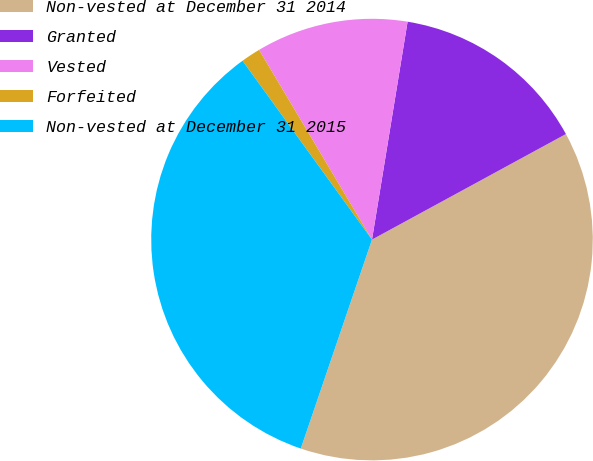<chart> <loc_0><loc_0><loc_500><loc_500><pie_chart><fcel>Non-vested at December 31 2014<fcel>Granted<fcel>Vested<fcel>Forfeited<fcel>Non-vested at December 31 2015<nl><fcel>38.16%<fcel>14.49%<fcel>11.12%<fcel>1.43%<fcel>34.8%<nl></chart> 